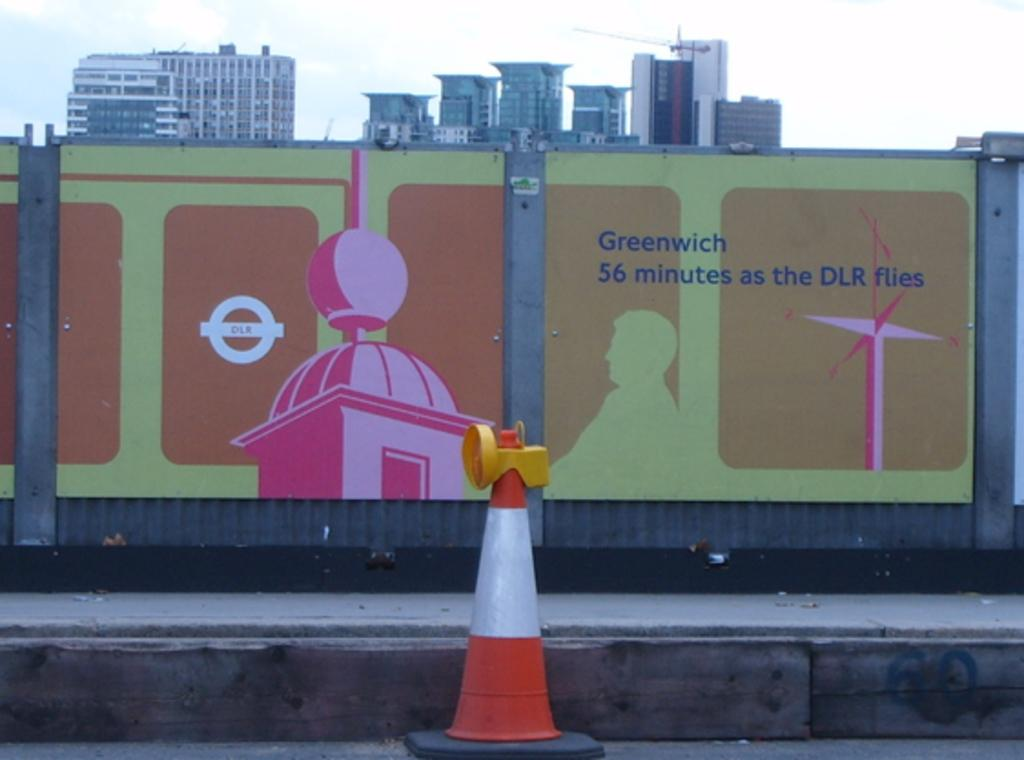<image>
Render a clear and concise summary of the photo. A sign on the side of a wall indicates it takes 56 minutes to reach Greenwich by flying DLR. 